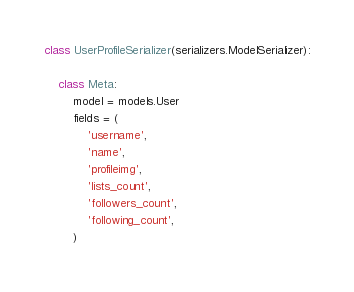Convert code to text. <code><loc_0><loc_0><loc_500><loc_500><_Python_>
class UserProfileSerializer(serializers.ModelSerializer):

    class Meta:
        model = models.User
        fields = (
            'username',
            'name',
            'profileimg',
            'lists_count',
            'followers_count',
            'following_count',
        )

</code> 